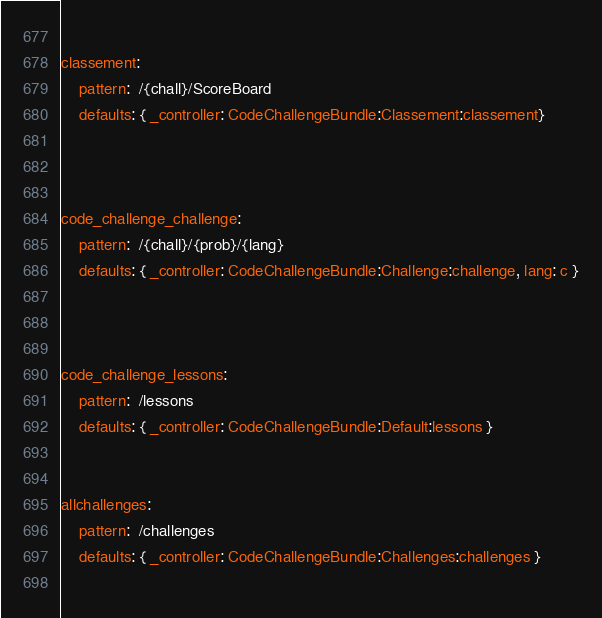Convert code to text. <code><loc_0><loc_0><loc_500><loc_500><_YAML_>    
classement:
    pattern:  /{chall}/ScoreBoard
    defaults: { _controller: CodeChallengeBundle:Classement:classement}
    

 
code_challenge_challenge:
    pattern:  /{chall}/{prob}/{lang}
    defaults: { _controller: CodeChallengeBundle:Challenge:challenge, lang: c }


    
code_challenge_lessons:
    pattern:  /lessons
    defaults: { _controller: CodeChallengeBundle:Default:lessons }

    
allchallenges:
    pattern:  /challenges
    defaults: { _controller: CodeChallengeBundle:Challenges:challenges }
    
</code> 